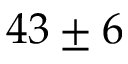<formula> <loc_0><loc_0><loc_500><loc_500>4 3 \pm 6</formula> 